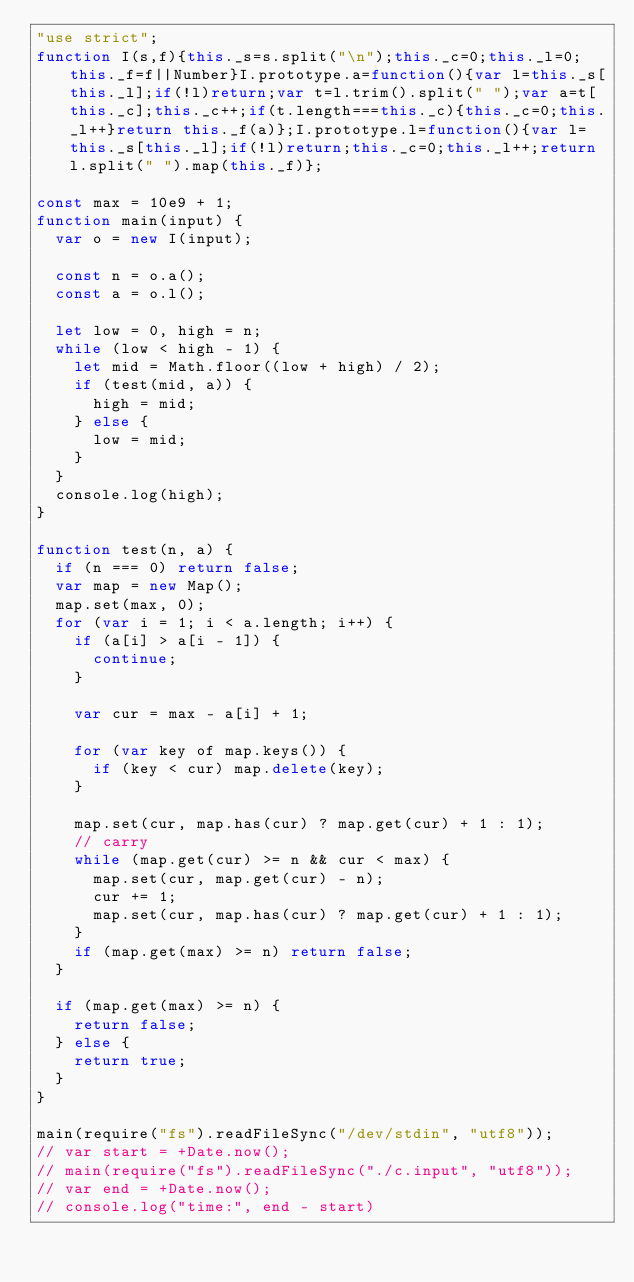<code> <loc_0><loc_0><loc_500><loc_500><_JavaScript_>"use strict";
function I(s,f){this._s=s.split("\n");this._c=0;this._l=0;this._f=f||Number}I.prototype.a=function(){var l=this._s[this._l];if(!l)return;var t=l.trim().split(" ");var a=t[this._c];this._c++;if(t.length===this._c){this._c=0;this._l++}return this._f(a)};I.prototype.l=function(){var l=this._s[this._l];if(!l)return;this._c=0;this._l++;return l.split(" ").map(this._f)};

const max = 10e9 + 1;
function main(input) {
  var o = new I(input);

  const n = o.a();
  const a = o.l();

  let low = 0, high = n;
  while (low < high - 1) {
    let mid = Math.floor((low + high) / 2);
    if (test(mid, a)) {
      high = mid;
    } else {
      low = mid;
    }
  }
  console.log(high);
}

function test(n, a) {
  if (n === 0) return false;
  var map = new Map();
  map.set(max, 0);
  for (var i = 1; i < a.length; i++) {
    if (a[i] > a[i - 1]) {
      continue;
    }

    var cur = max - a[i] + 1;

    for (var key of map.keys()) {
      if (key < cur) map.delete(key);
    }

    map.set(cur, map.has(cur) ? map.get(cur) + 1 : 1);
    // carry
    while (map.get(cur) >= n && cur < max) {
      map.set(cur, map.get(cur) - n);
      cur += 1;
      map.set(cur, map.has(cur) ? map.get(cur) + 1 : 1);
    }
    if (map.get(max) >= n) return false;
  }

  if (map.get(max) >= n) {
    return false;
  } else {
    return true;
  }
}

main(require("fs").readFileSync("/dev/stdin", "utf8"));
// var start = +Date.now();
// main(require("fs").readFileSync("./c.input", "utf8"));
// var end = +Date.now();
// console.log("time:", end - start)</code> 